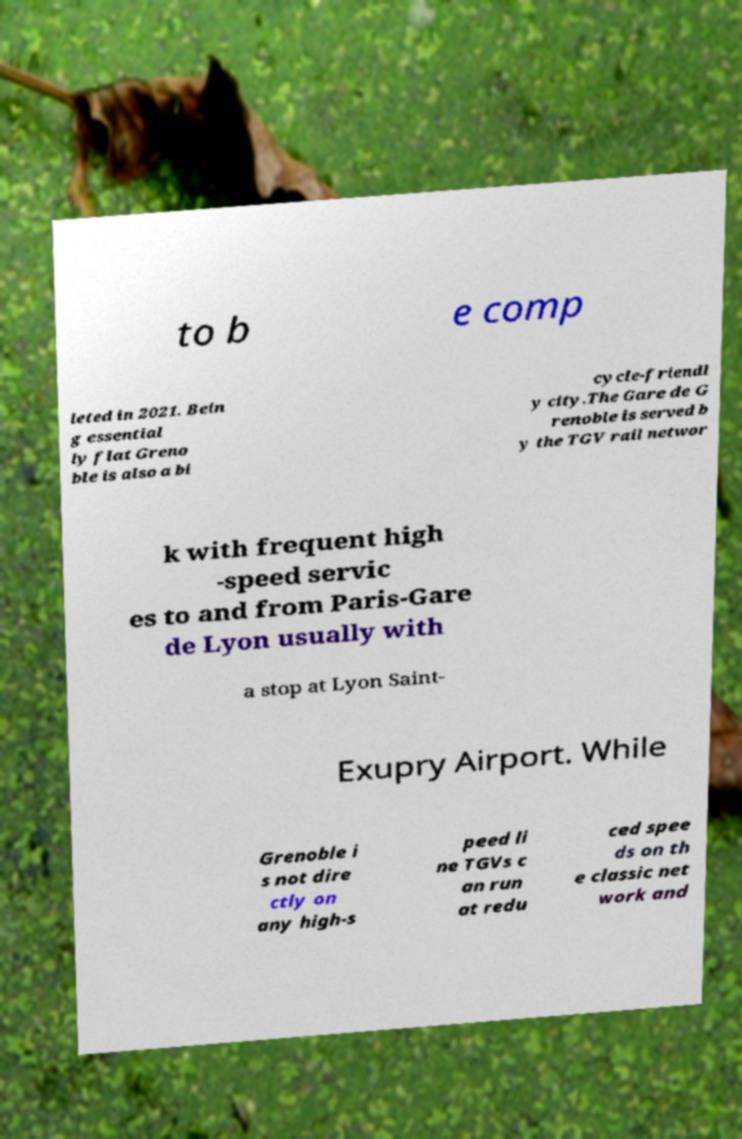Can you read and provide the text displayed in the image?This photo seems to have some interesting text. Can you extract and type it out for me? to b e comp leted in 2021. Bein g essential ly flat Greno ble is also a bi cycle-friendl y city.The Gare de G renoble is served b y the TGV rail networ k with frequent high -speed servic es to and from Paris-Gare de Lyon usually with a stop at Lyon Saint- Exupry Airport. While Grenoble i s not dire ctly on any high-s peed li ne TGVs c an run at redu ced spee ds on th e classic net work and 